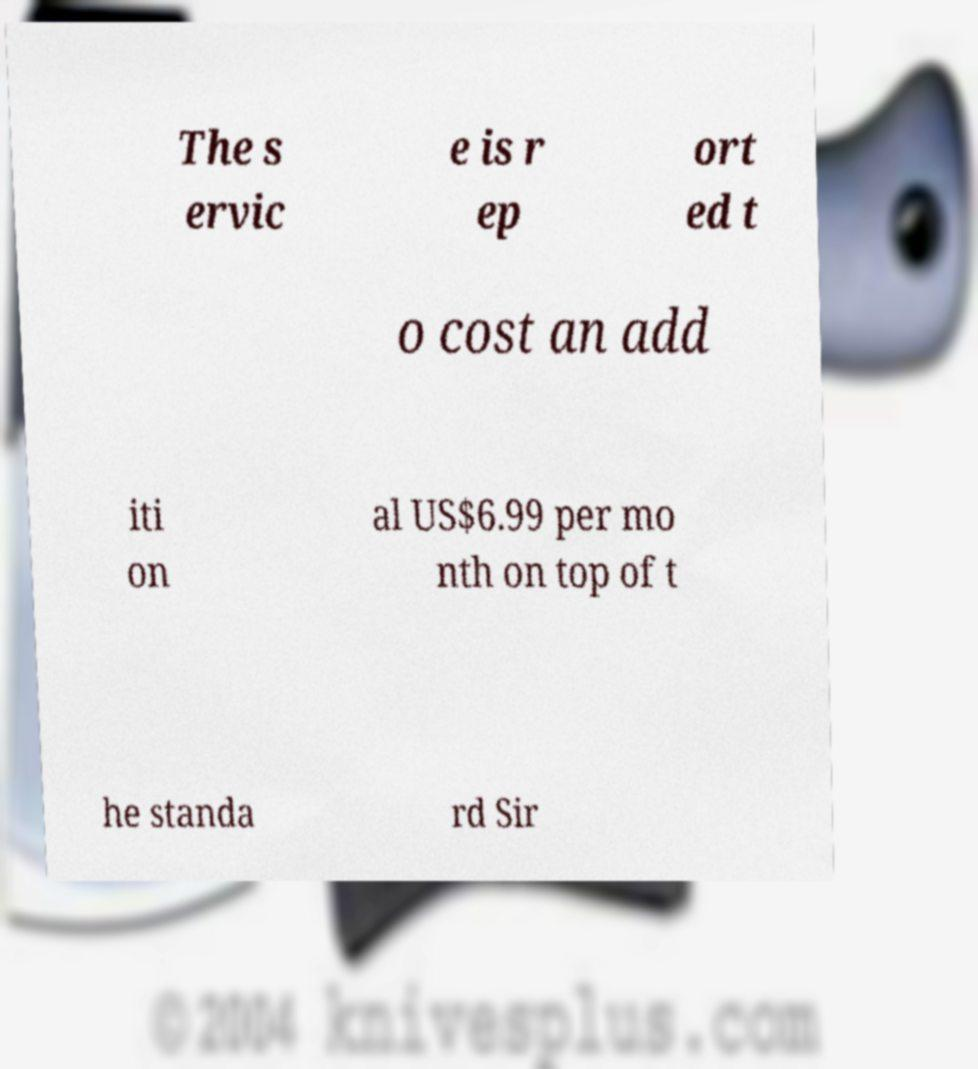Can you read and provide the text displayed in the image?This photo seems to have some interesting text. Can you extract and type it out for me? The s ervic e is r ep ort ed t o cost an add iti on al US$6.99 per mo nth on top of t he standa rd Sir 